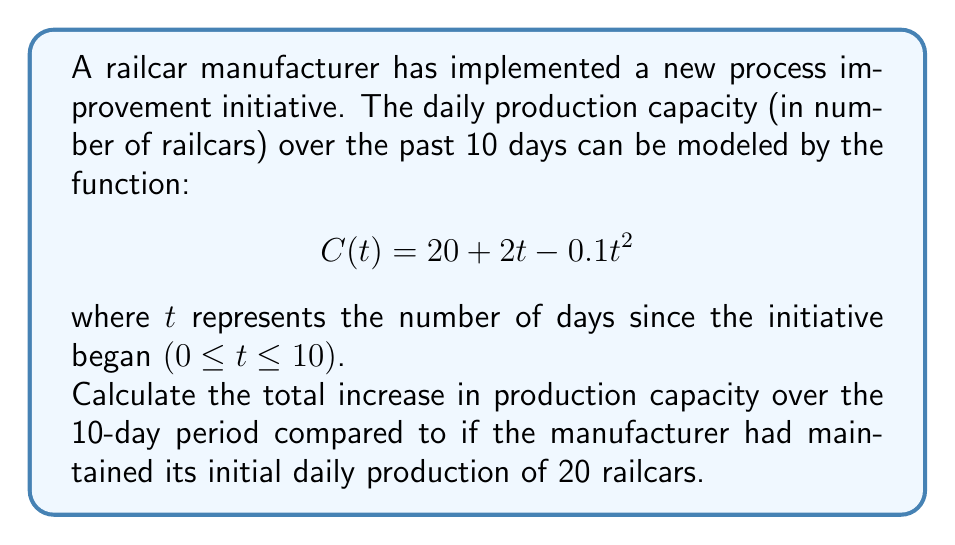Solve this math problem. To solve this problem, we need to follow these steps:

1) First, let's find the total production over the 10-day period with the new initiative:
   
   We need to integrate the function $C(t)$ from $t=0$ to $t=10$:

   $$\int_0^{10} (20 + 2t - 0.1t^2) dt$$

2) Integrate each term:

   $$[20t + t^2 - \frac{0.1t^3}{3}]_0^{10}$$

3) Evaluate at the limits:

   $$(200 + 100 - \frac{100}{3}) - (0 + 0 - 0) = 266.67$$

4) Now, if the manufacturer had maintained its initial production of 20 railcars per day, the total production over 10 days would be:

   $$20 * 10 = 200$$

5) The increase in production is the difference between these two values:

   $$266.67 - 200 = 66.67$$

Therefore, the total increase in production capacity over the 10-day period is approximately 66.67 railcars.
Answer: 66.67 railcars 